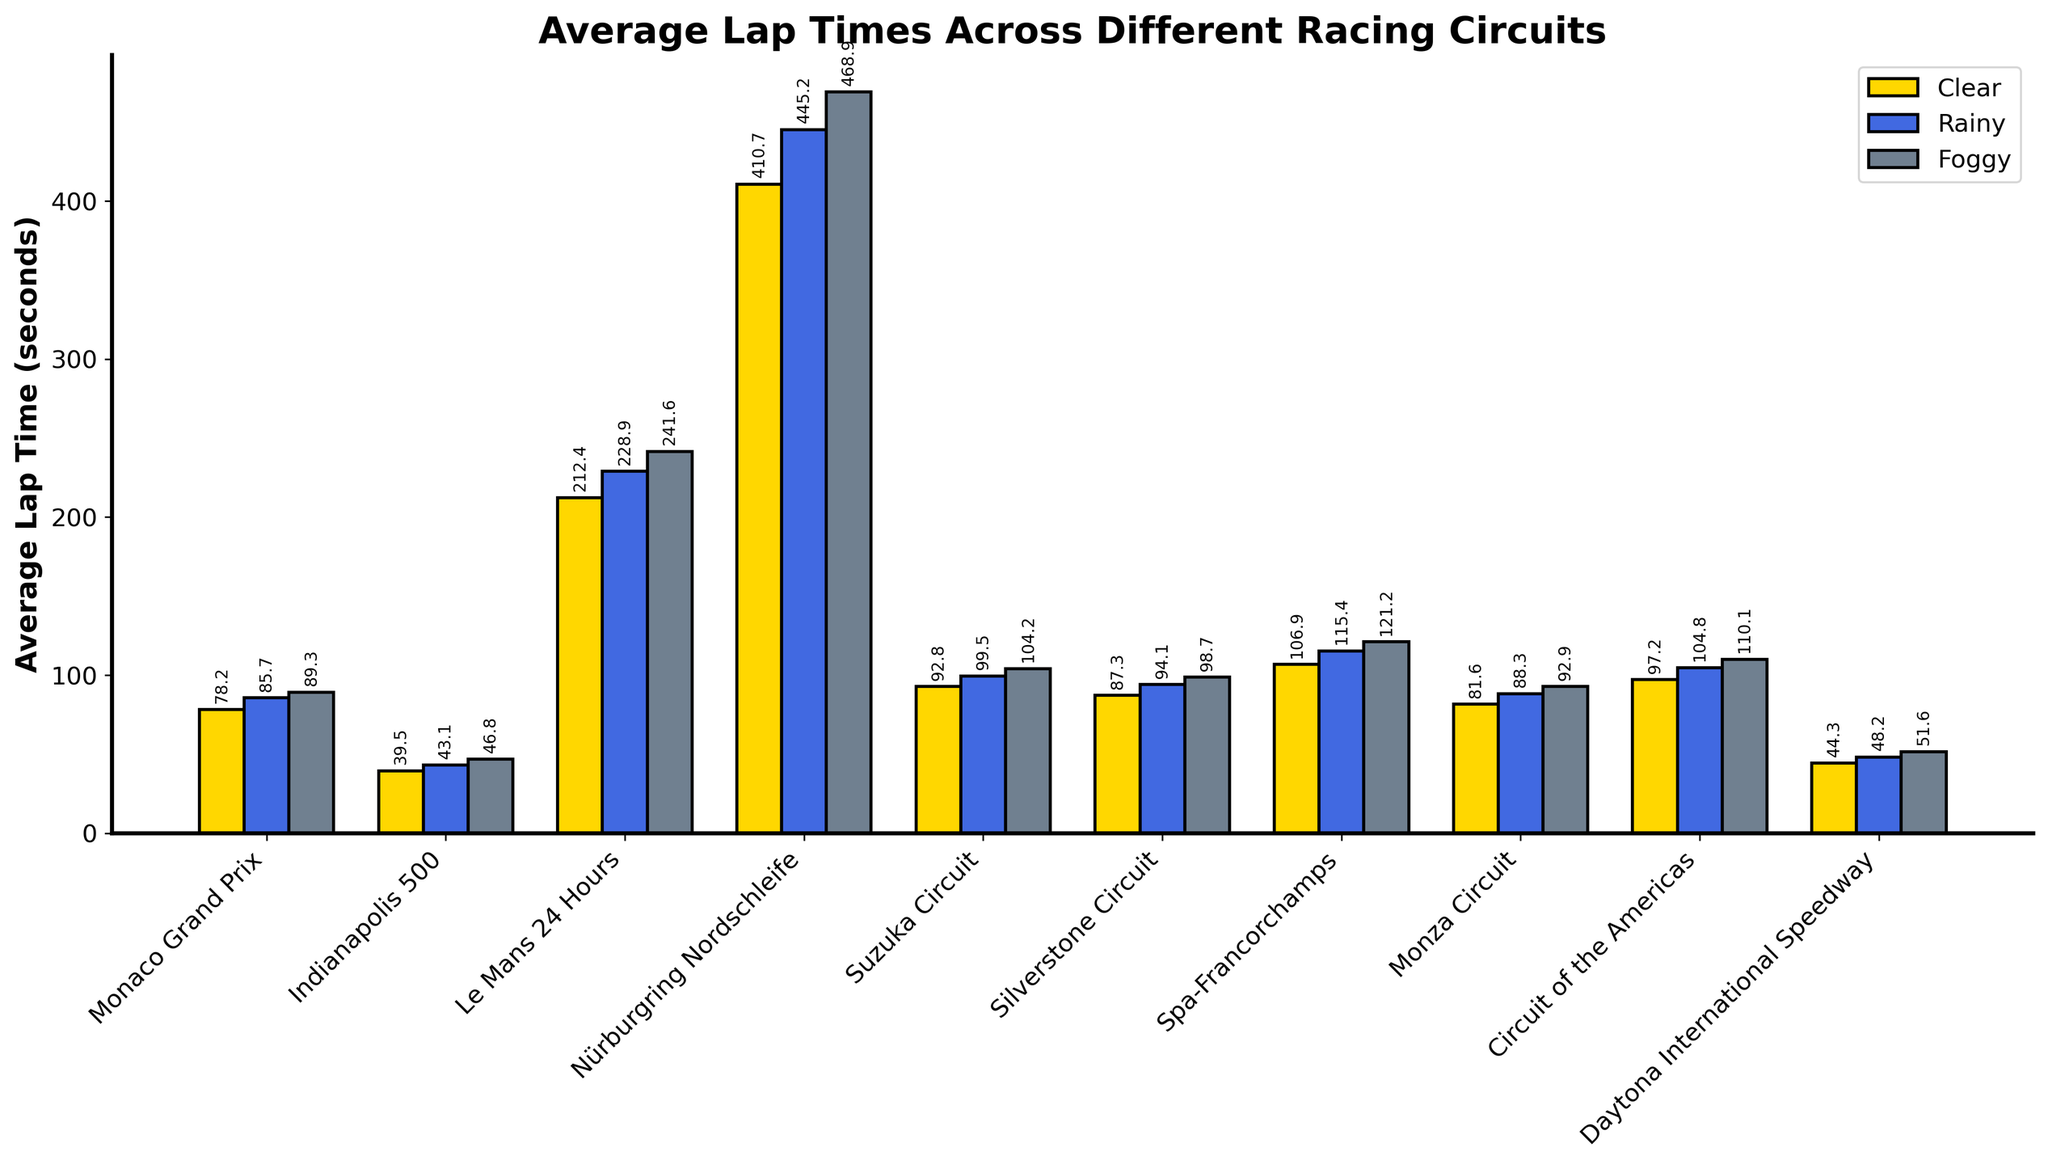What is the average lap time across all circuits during clear conditions? Sum the clear-condition lap times and then divide by the number of circuits:
- (78.2 + 39.5 + 212.4 + 410.7 + 92.8 + 87.3 + 106.9 + 81.6 + 97.2 + 44.3) / 10 
- Total: 1251.9
- Average: 1251.9 / 10 = 125.19 seconds
Answer: 125.19 Does any circuit have the same ranking for lap times across all conditions (clear, rainy, foggy)? Identify the ranks of each circuit's lap times for clear, rainy, and foggy conditions. Since no circuit maintains the same ranking across all condition categories, none match this criterion.
Answer: No 